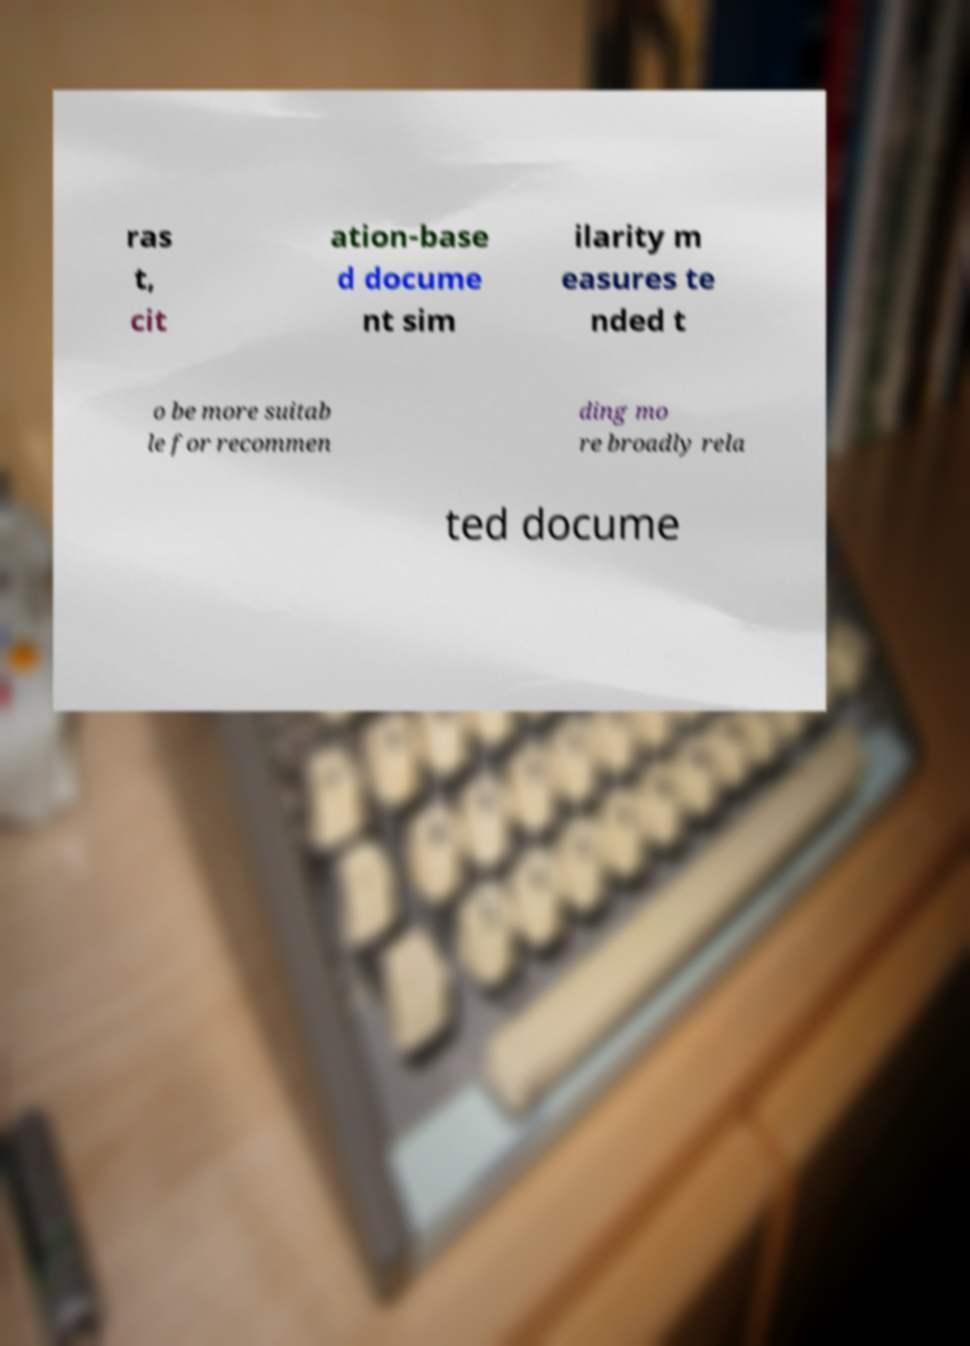There's text embedded in this image that I need extracted. Can you transcribe it verbatim? ras t, cit ation-base d docume nt sim ilarity m easures te nded t o be more suitab le for recommen ding mo re broadly rela ted docume 